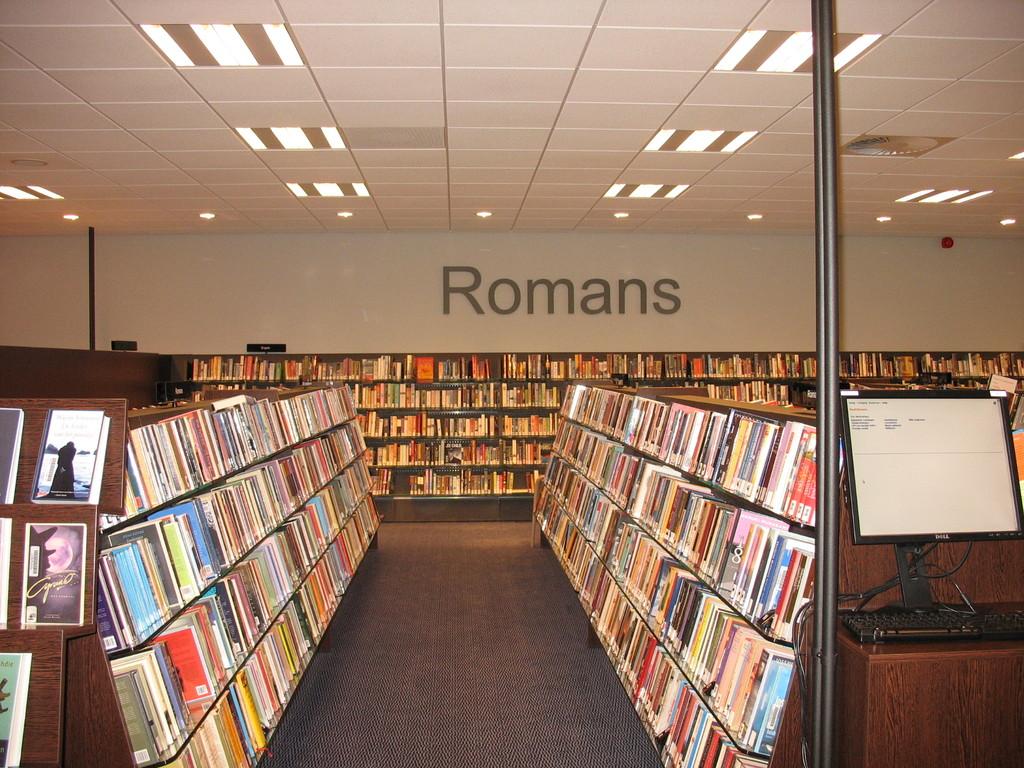What subject are the books on the back shelf about?
Your answer should be very brief. Romans. 